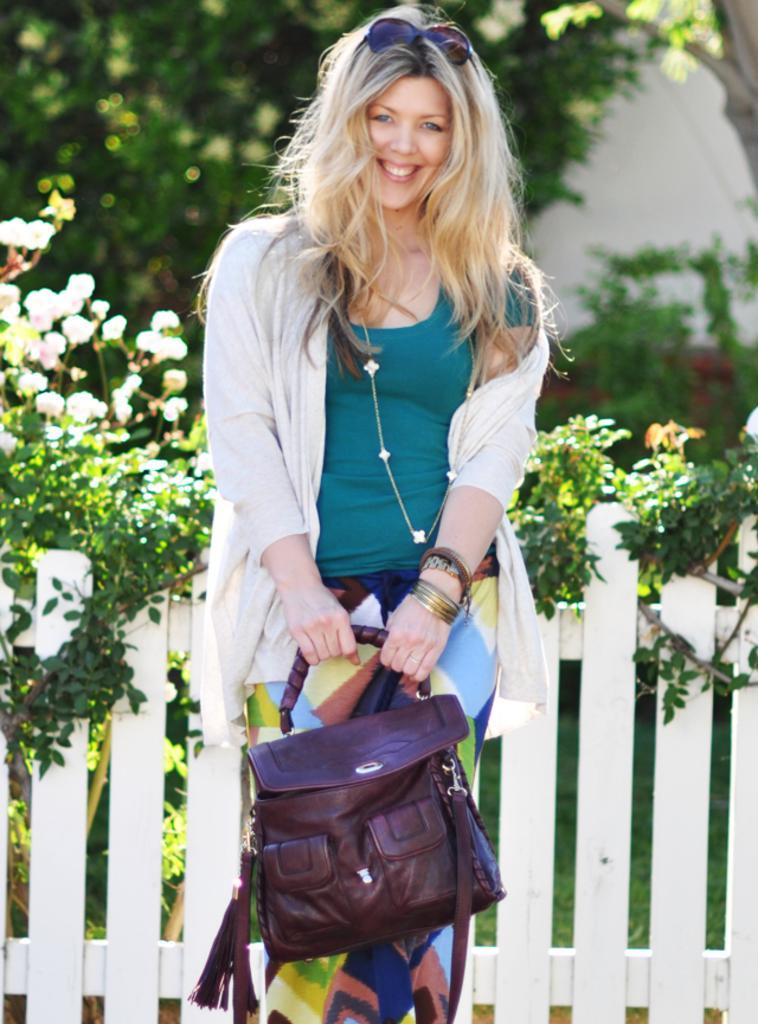In one or two sentences, can you explain what this image depicts? In this image the woman is standing and holding a bag. 